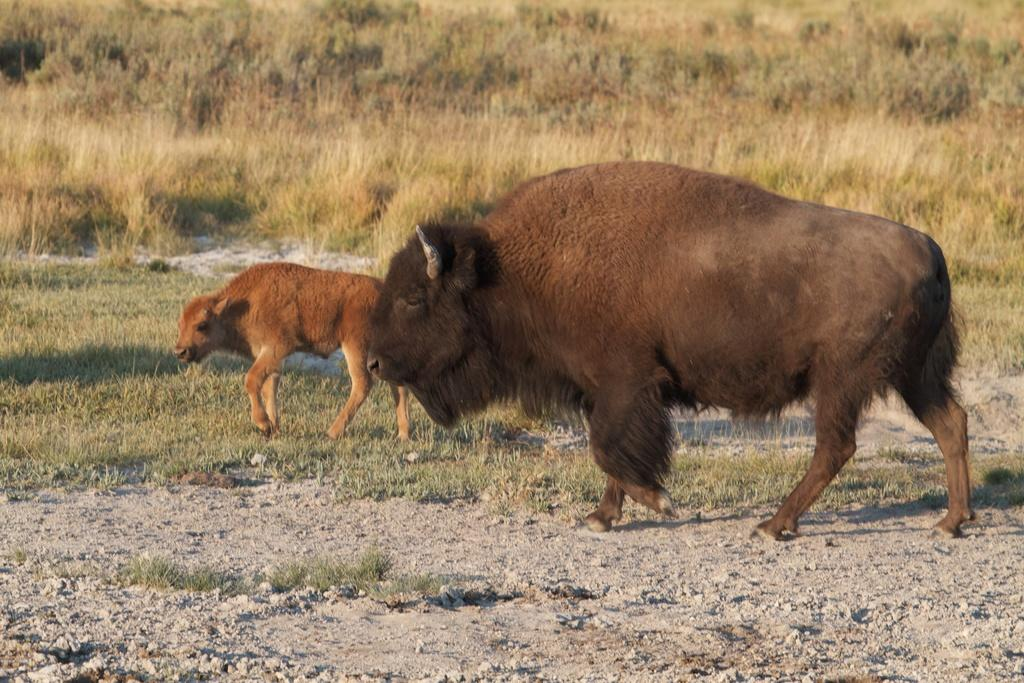How many animals can be seen in the image? There are two animals in the image. What colors are the animals? The animals are in brown and cream color. What can be seen in the background of the image? There are trees in the background of the image. What color is the grass in the background? The grass in the background is green. What type of business does the governor own in the image? There is no mention of a business or a governor in the image; it features two animals and a background with trees and green grass. 